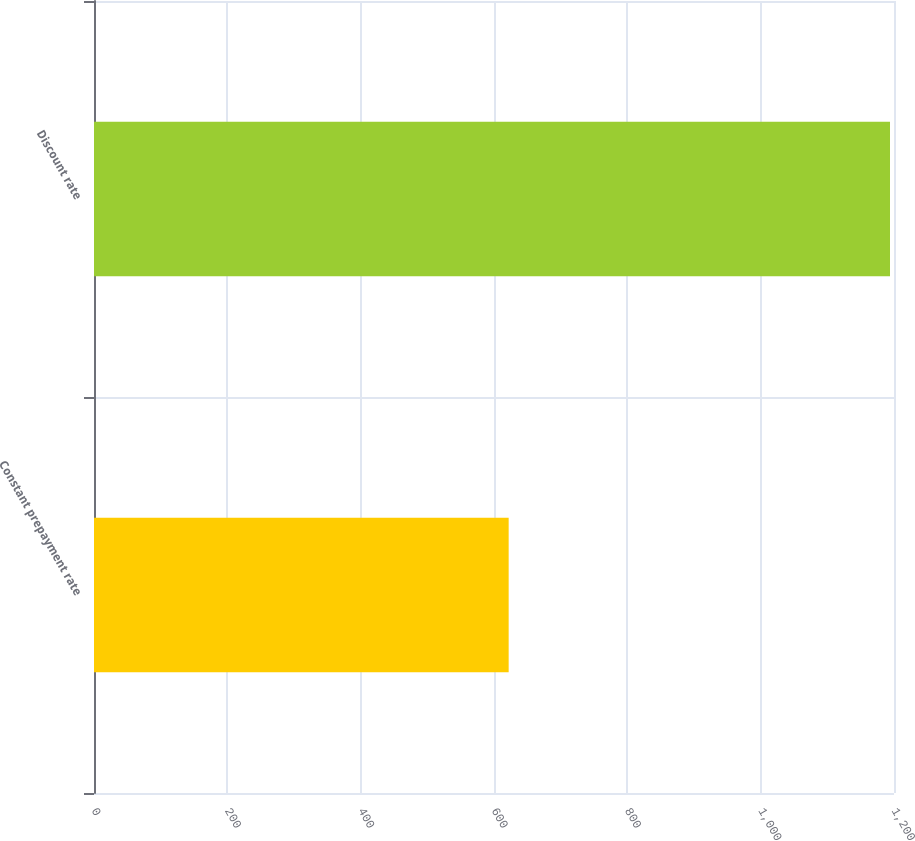<chart> <loc_0><loc_0><loc_500><loc_500><bar_chart><fcel>Constant prepayment rate<fcel>Discount rate<nl><fcel>622<fcel>1194<nl></chart> 